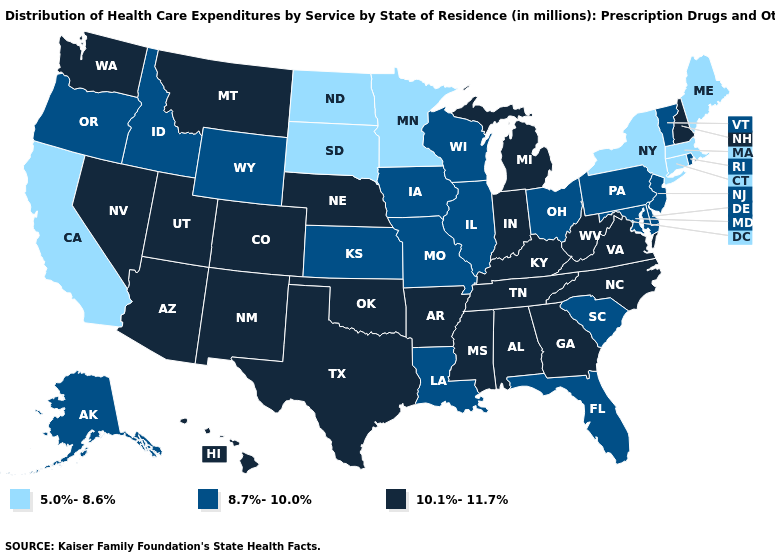Name the states that have a value in the range 10.1%-11.7%?
Quick response, please. Alabama, Arizona, Arkansas, Colorado, Georgia, Hawaii, Indiana, Kentucky, Michigan, Mississippi, Montana, Nebraska, Nevada, New Hampshire, New Mexico, North Carolina, Oklahoma, Tennessee, Texas, Utah, Virginia, Washington, West Virginia. What is the value of South Dakota?
Write a very short answer. 5.0%-8.6%. Does Illinois have the highest value in the USA?
Short answer required. No. Does Missouri have a lower value than South Dakota?
Keep it brief. No. How many symbols are there in the legend?
Short answer required. 3. What is the highest value in states that border New Jersey?
Answer briefly. 8.7%-10.0%. Which states have the lowest value in the West?
Write a very short answer. California. What is the highest value in the West ?
Be succinct. 10.1%-11.7%. Name the states that have a value in the range 5.0%-8.6%?
Give a very brief answer. California, Connecticut, Maine, Massachusetts, Minnesota, New York, North Dakota, South Dakota. Name the states that have a value in the range 5.0%-8.6%?
Short answer required. California, Connecticut, Maine, Massachusetts, Minnesota, New York, North Dakota, South Dakota. What is the value of Arizona?
Keep it brief. 10.1%-11.7%. What is the value of Vermont?
Write a very short answer. 8.7%-10.0%. Is the legend a continuous bar?
Short answer required. No. Name the states that have a value in the range 10.1%-11.7%?
Answer briefly. Alabama, Arizona, Arkansas, Colorado, Georgia, Hawaii, Indiana, Kentucky, Michigan, Mississippi, Montana, Nebraska, Nevada, New Hampshire, New Mexico, North Carolina, Oklahoma, Tennessee, Texas, Utah, Virginia, Washington, West Virginia. What is the highest value in the USA?
Quick response, please. 10.1%-11.7%. 